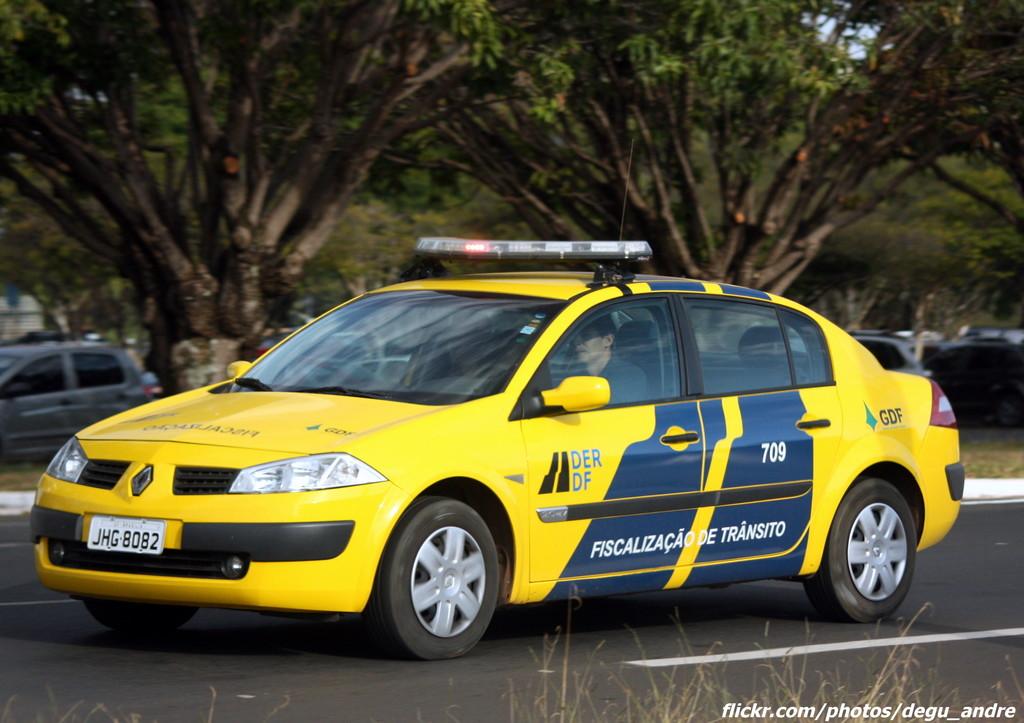What is the license plate number?
Ensure brevity in your answer.  Jhg 8082. 